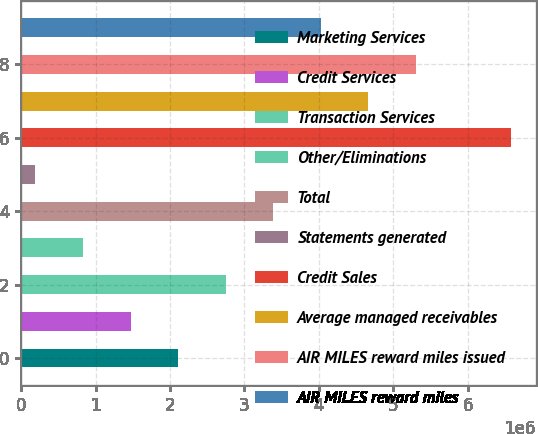<chart> <loc_0><loc_0><loc_500><loc_500><bar_chart><fcel>Marketing Services<fcel>Credit Services<fcel>Transaction Services<fcel>Other/Eliminations<fcel>Total<fcel>Statements generated<fcel>Credit Sales<fcel>Average managed receivables<fcel>AIR MILES reward miles issued<fcel>AIR MILES reward miles<nl><fcel>2.10848e+06<fcel>1.46929e+06<fcel>2.74767e+06<fcel>830099<fcel>3.38686e+06<fcel>190910<fcel>6.5828e+06<fcel>4.66523e+06<fcel>5.30442e+06<fcel>4.02604e+06<nl></chart> 